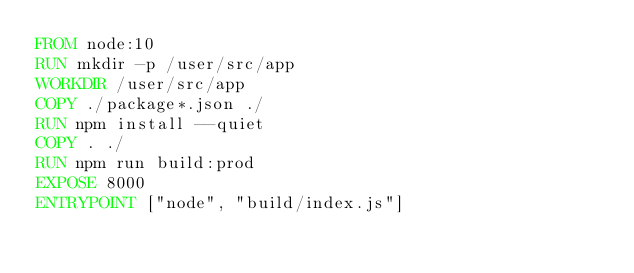<code> <loc_0><loc_0><loc_500><loc_500><_Dockerfile_>FROM node:10
RUN mkdir -p /user/src/app
WORKDIR /user/src/app
COPY ./package*.json ./
RUN npm install --quiet
COPY . ./
RUN npm run build:prod
EXPOSE 8000
ENTRYPOINT ["node", "build/index.js"]
</code> 